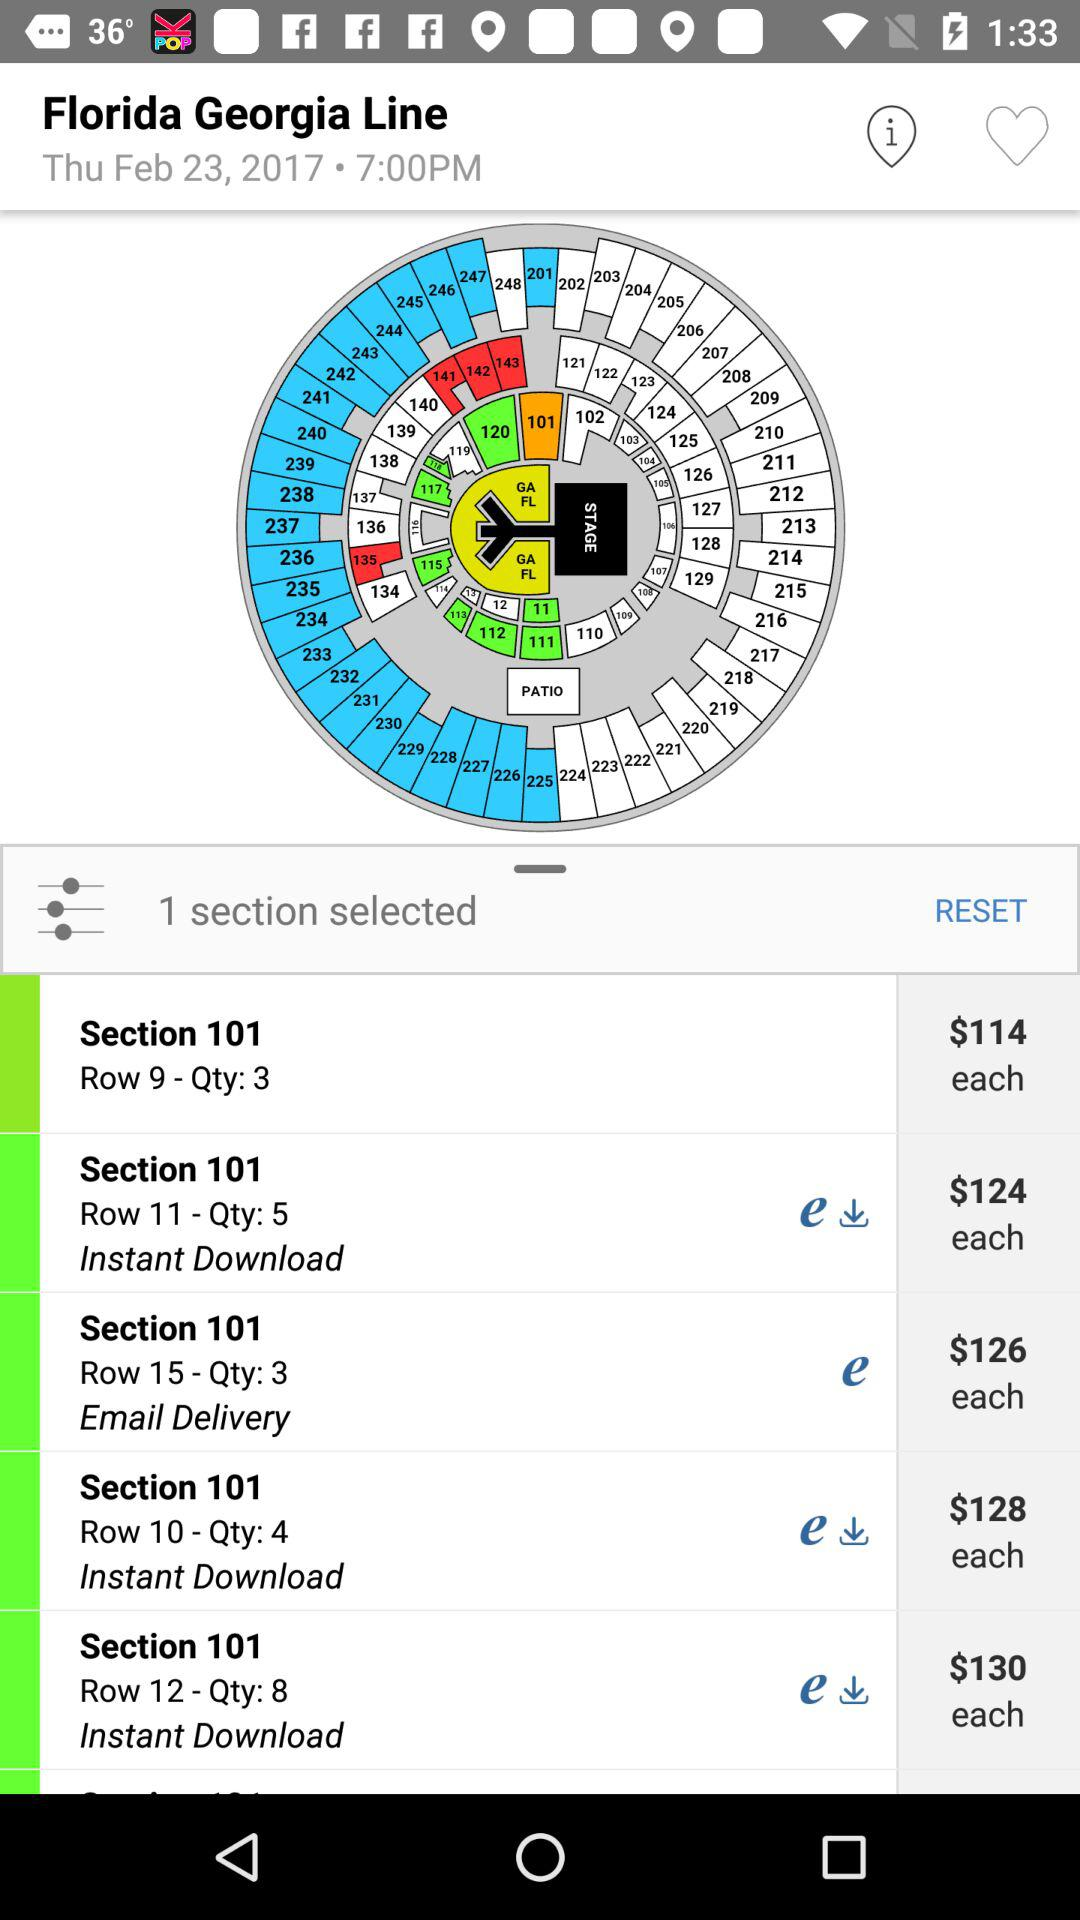Which are the different sections? The section is 101. 